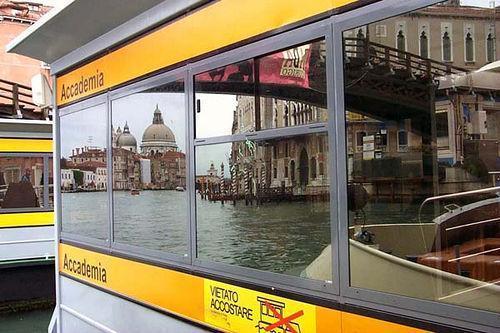How many chairs don't have a dog on them?
Give a very brief answer. 0. 